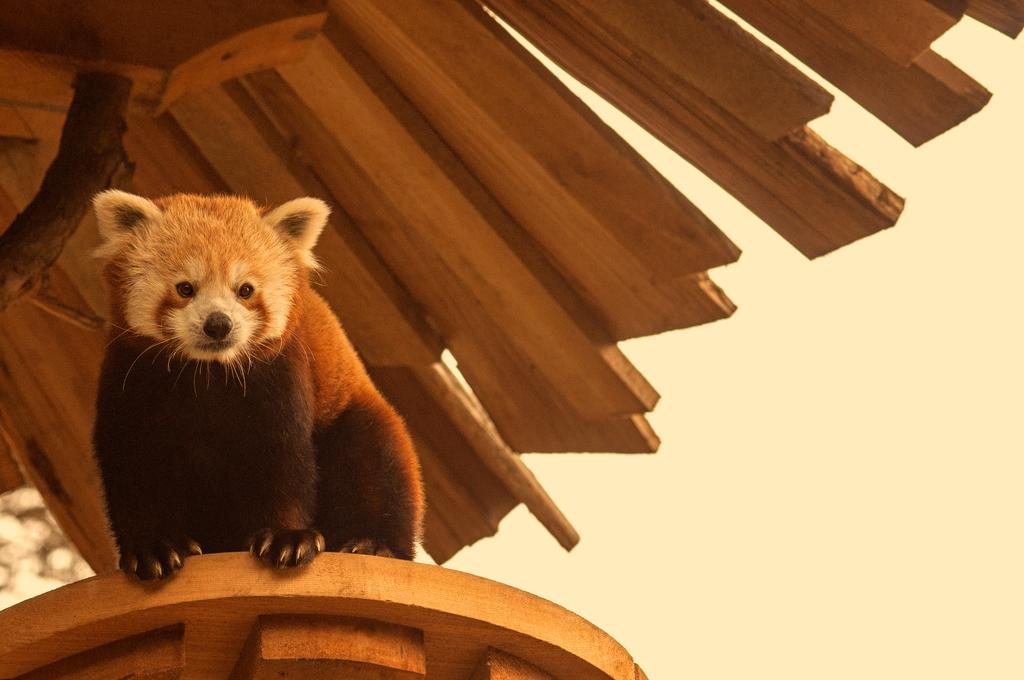What type of animal is in the image? There is a red panda in the image. Where is the red panda located? The red panda is sitting on a table. What can be seen above the table in the image? There is a wooden roof in the image. What type of stem can be seen growing from the red panda's back in the image? There is no stem growing from the red panda's back in the image. How many cows are present in the image? There are no cows present in the image. 